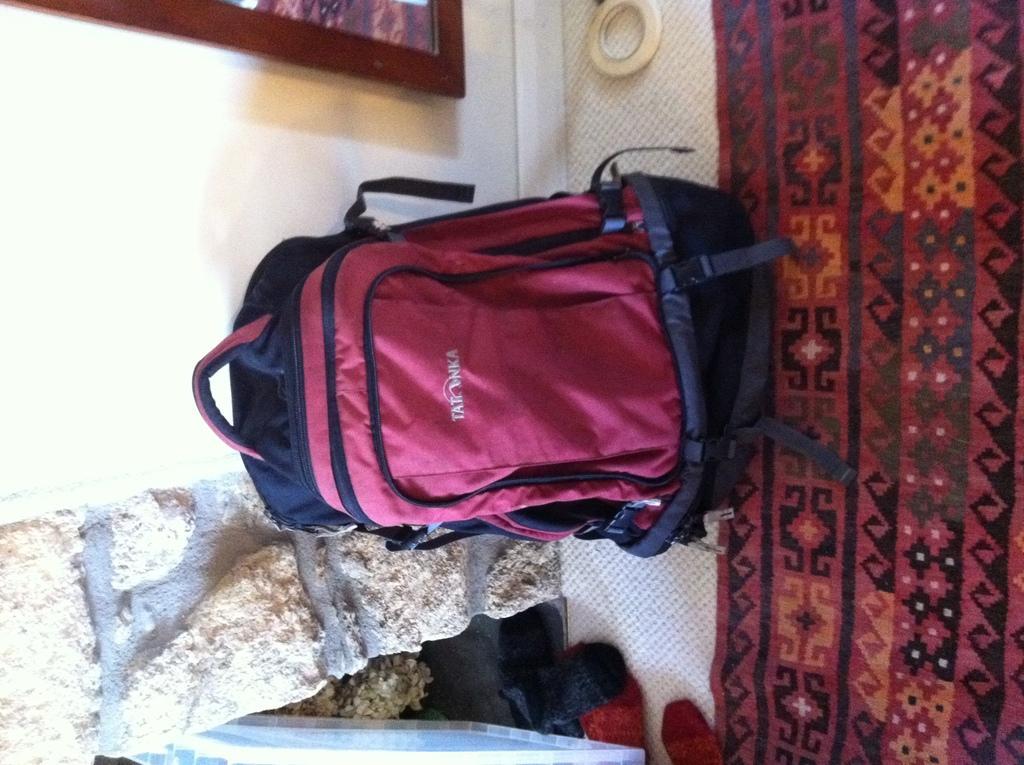Describe this image in one or two sentences. In this picture there is a bag kept on a bed ,in the background we observe photo frame and a brick wall. 